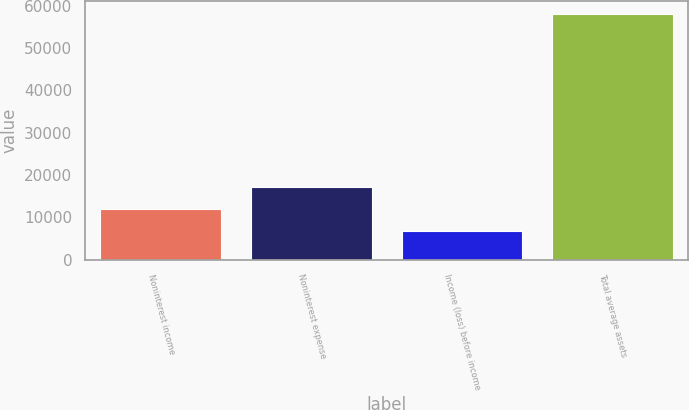Convert chart. <chart><loc_0><loc_0><loc_500><loc_500><bar_chart><fcel>Noninterest income<fcel>Noninterest expense<fcel>Income (loss) before income<fcel>Total average assets<nl><fcel>11938.1<fcel>17072.2<fcel>6804<fcel>58145<nl></chart> 